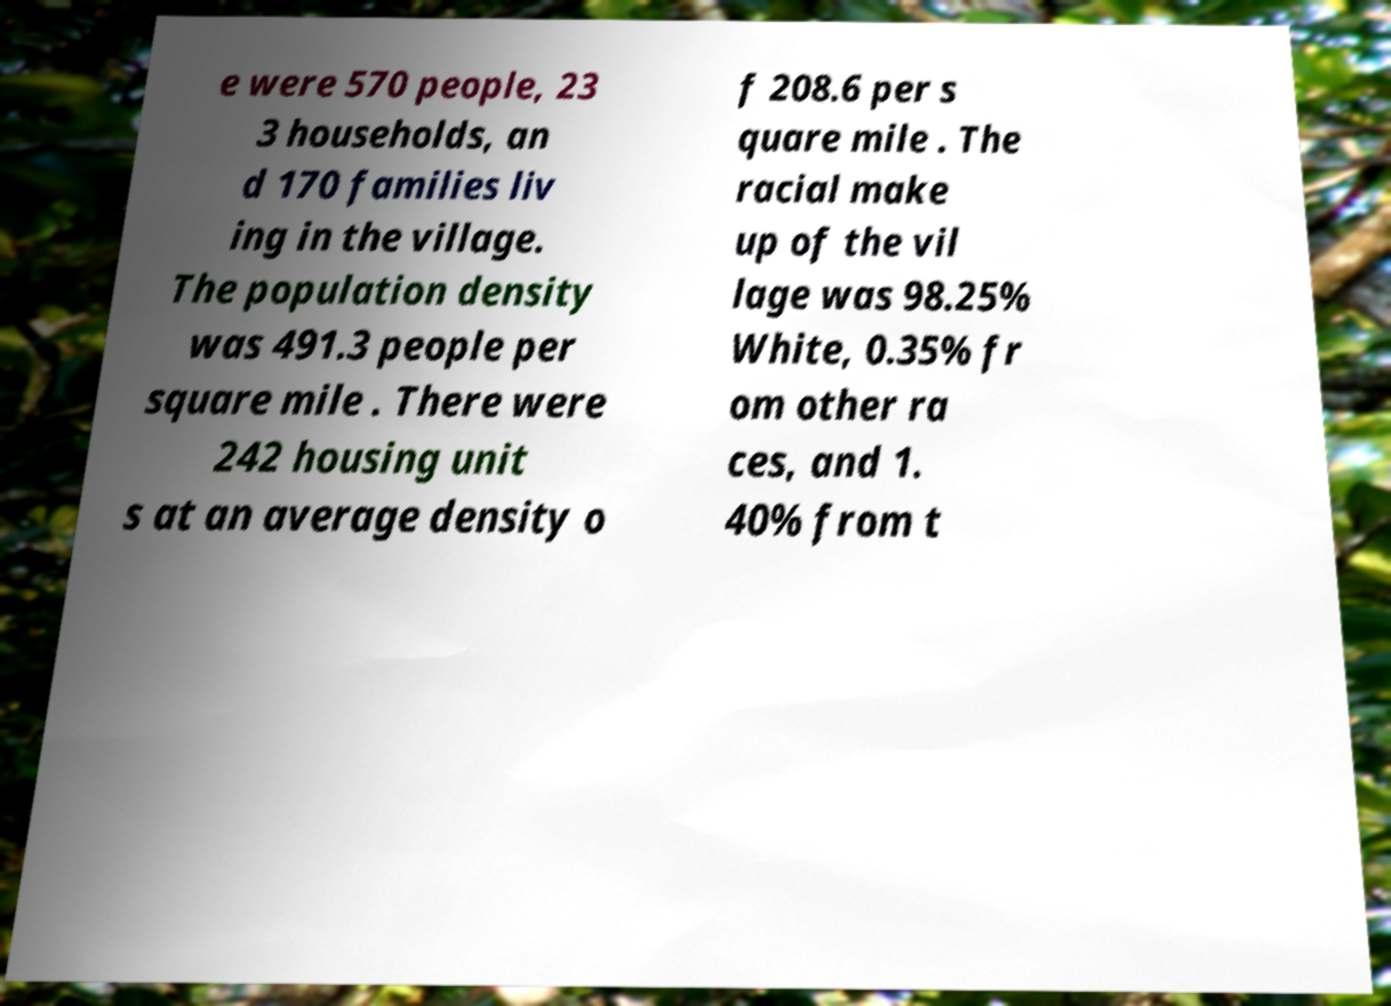Could you assist in decoding the text presented in this image and type it out clearly? e were 570 people, 23 3 households, an d 170 families liv ing in the village. The population density was 491.3 people per square mile . There were 242 housing unit s at an average density o f 208.6 per s quare mile . The racial make up of the vil lage was 98.25% White, 0.35% fr om other ra ces, and 1. 40% from t 